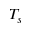<formula> <loc_0><loc_0><loc_500><loc_500>T _ { s }</formula> 